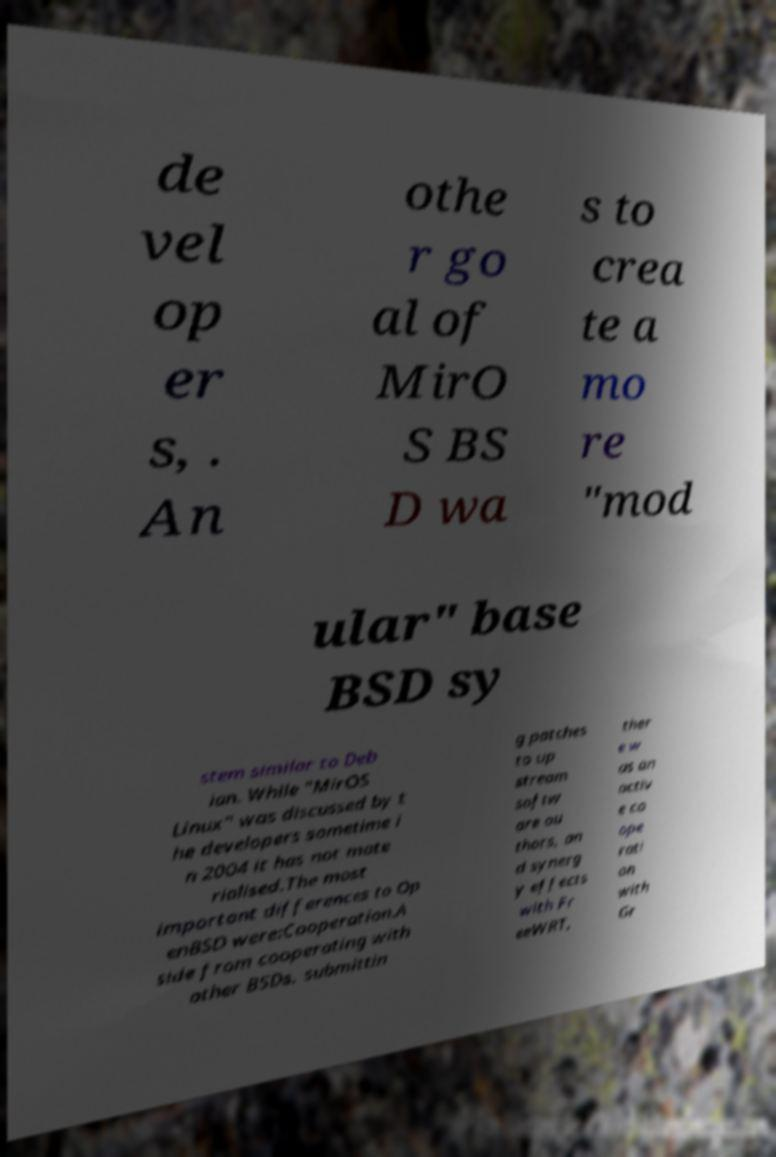There's text embedded in this image that I need extracted. Can you transcribe it verbatim? de vel op er s, . An othe r go al of MirO S BS D wa s to crea te a mo re "mod ular" base BSD sy stem similar to Deb ian. While "MirOS Linux" was discussed by t he developers sometime i n 2004 it has not mate rialised.The most important differences to Op enBSD were:Cooperation.A side from cooperating with other BSDs, submittin g patches to up stream softw are au thors, an d synerg y effects with Fr eeWRT, ther e w as an activ e co ope rati on with Gr 